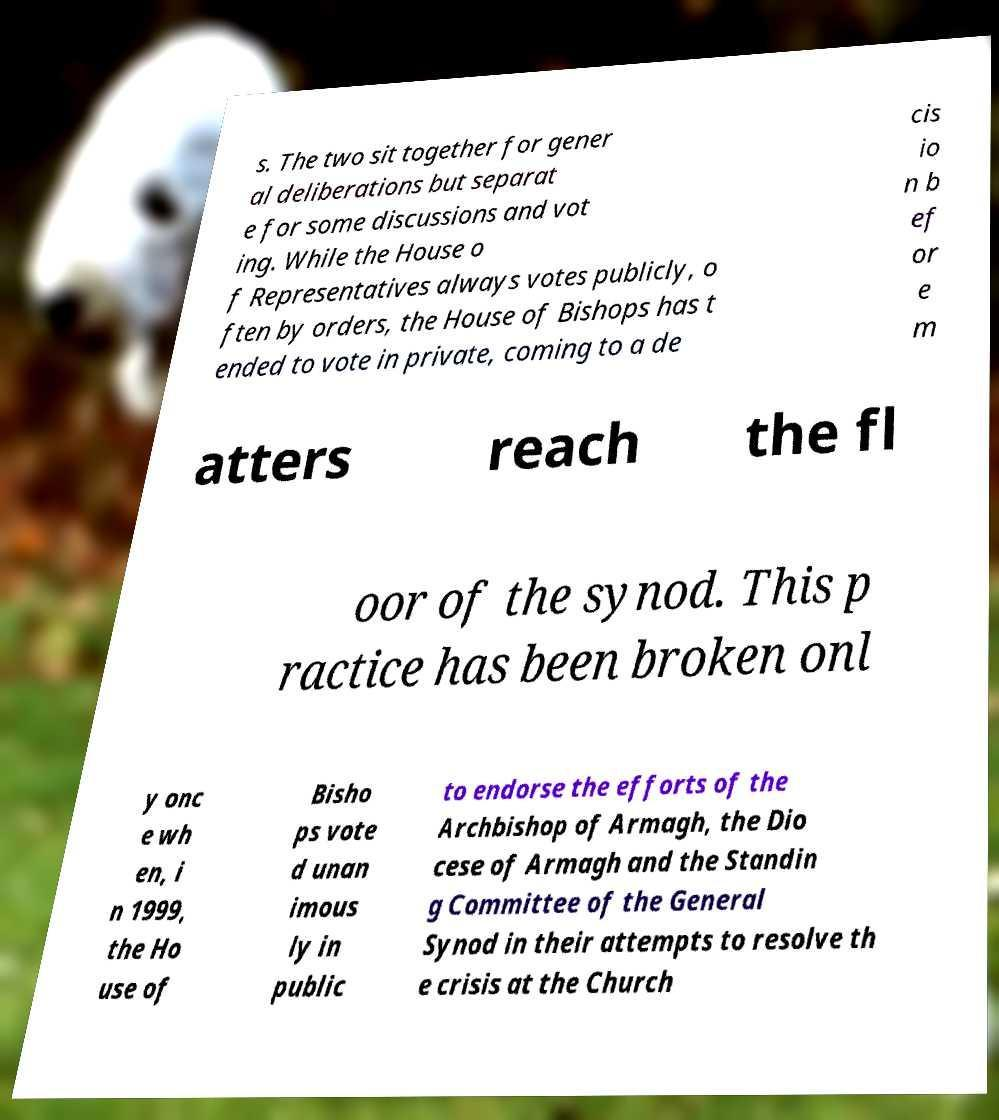Please read and relay the text visible in this image. What does it say? s. The two sit together for gener al deliberations but separat e for some discussions and vot ing. While the House o f Representatives always votes publicly, o ften by orders, the House of Bishops has t ended to vote in private, coming to a de cis io n b ef or e m atters reach the fl oor of the synod. This p ractice has been broken onl y onc e wh en, i n 1999, the Ho use of Bisho ps vote d unan imous ly in public to endorse the efforts of the Archbishop of Armagh, the Dio cese of Armagh and the Standin g Committee of the General Synod in their attempts to resolve th e crisis at the Church 